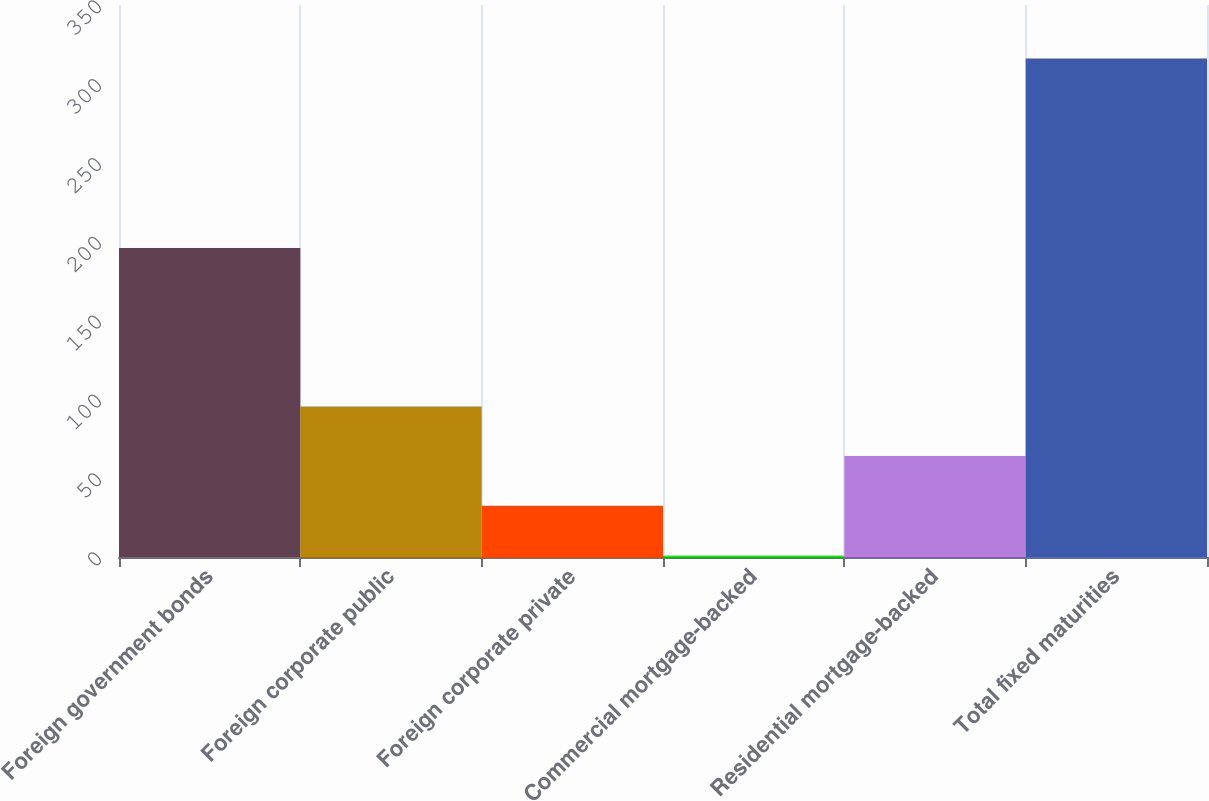Convert chart to OTSL. <chart><loc_0><loc_0><loc_500><loc_500><bar_chart><fcel>Foreign government bonds<fcel>Foreign corporate public<fcel>Foreign corporate private<fcel>Commercial mortgage-backed<fcel>Residential mortgage-backed<fcel>Total fixed maturities<nl><fcel>196<fcel>95.5<fcel>32.5<fcel>1<fcel>64<fcel>316<nl></chart> 